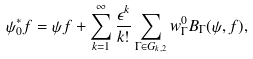<formula> <loc_0><loc_0><loc_500><loc_500>\psi ^ { * } _ { 0 } f = \psi f + \sum _ { k = 1 } ^ { \infty } \frac { \epsilon ^ { k } } { k ! } \sum _ { \Gamma \in G _ { k , 2 } } w ^ { 0 } _ { \Gamma } B _ { \Gamma } ( \psi , f ) ,</formula> 